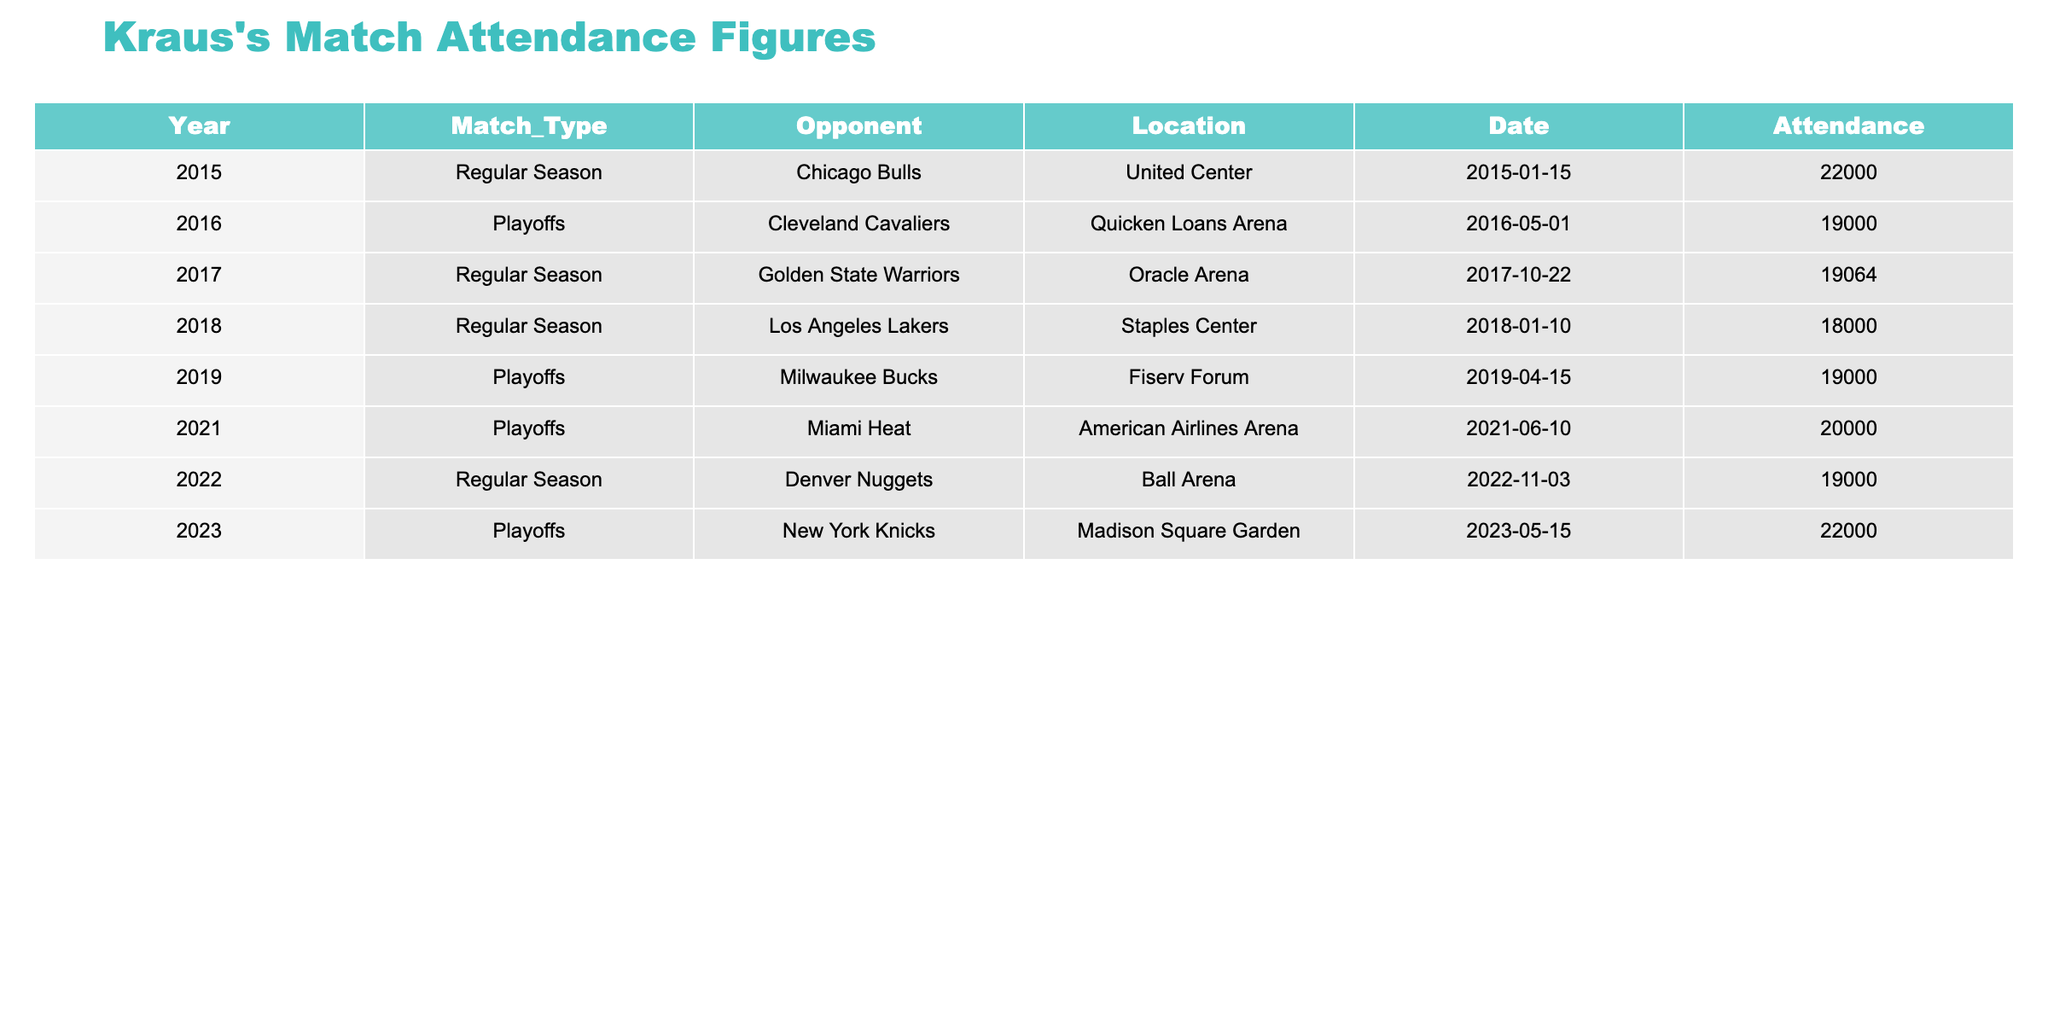What was the highest attendance recorded in Kraus's matches? Looking at the attendance figures, the highest recorded attendance is 22000, achieved in two matches: one in 2015 against the Chicago Bulls and one in 2023 against the New York Knicks.
Answer: 22000 In which year did Kraus have the lowest attendances? By examining the attendance numbers, the lowest figure is 18000, which occurred in 2018 during a match against the Los Angeles Lakers.
Answer: 2018 How many playoff matches did Kraus participate in? There are four entries labeled as playoff matches in the table: the ones against the Cleveland Cavaliers, Milwaukee Bucks, Miami Heat, and New York Knicks, indicating that Kraus participated in four playoff matches.
Answer: 4 What is the total attendance for all the matches in 2016? In 2016, there is one match listed against the Cleveland Cavaliers with an attendance of 19000, thus the total attendance for that year is simply 19000.
Answer: 19000 What was the average attendance across all matches? Adding the attendance figures together gives (22000 + 19000 + 19064 + 18000 + 19000 + 20000 + 19000 + 22000) = 139064. Dividing this total by the 8 matches results in an average attendance of 17383.
Answer: 17383 Did Kraus ever play at Madison Square Garden? The table indicates that Kraus played at Madison Square Garden in 2023 against the New York Knicks, confirming that he did play at this venue.
Answer: Yes How did the attendance figures change from 2015 to 2023? In 2015, the attendance was 22000, while in 2023 it also reached 22000. Therefore, there was no change in attendance figures from 2015 to 2023.
Answer: No change What was the difference in attendance between the playoff matches and regular season matches? The total attendance for the playoff matches is (19000 + 20000 + 19000 + 22000) = 80000 and for the regular season matches, it's (22000 + 19064 + 18000 + 19000) = 78064. The difference is 80000 - 78064 = 936.
Answer: 936 Which opponent drew the largest crowd in the playoffs? The highest attendance during a playoff match is 22000, observed during the match against the New York Knicks in 2023.
Answer: New York Knicks Which year saw Kraus facing the Golden State Warriors? Kraus faced the Golden State Warriors in 2017, during a regular season match as shown in the table.
Answer: 2017 